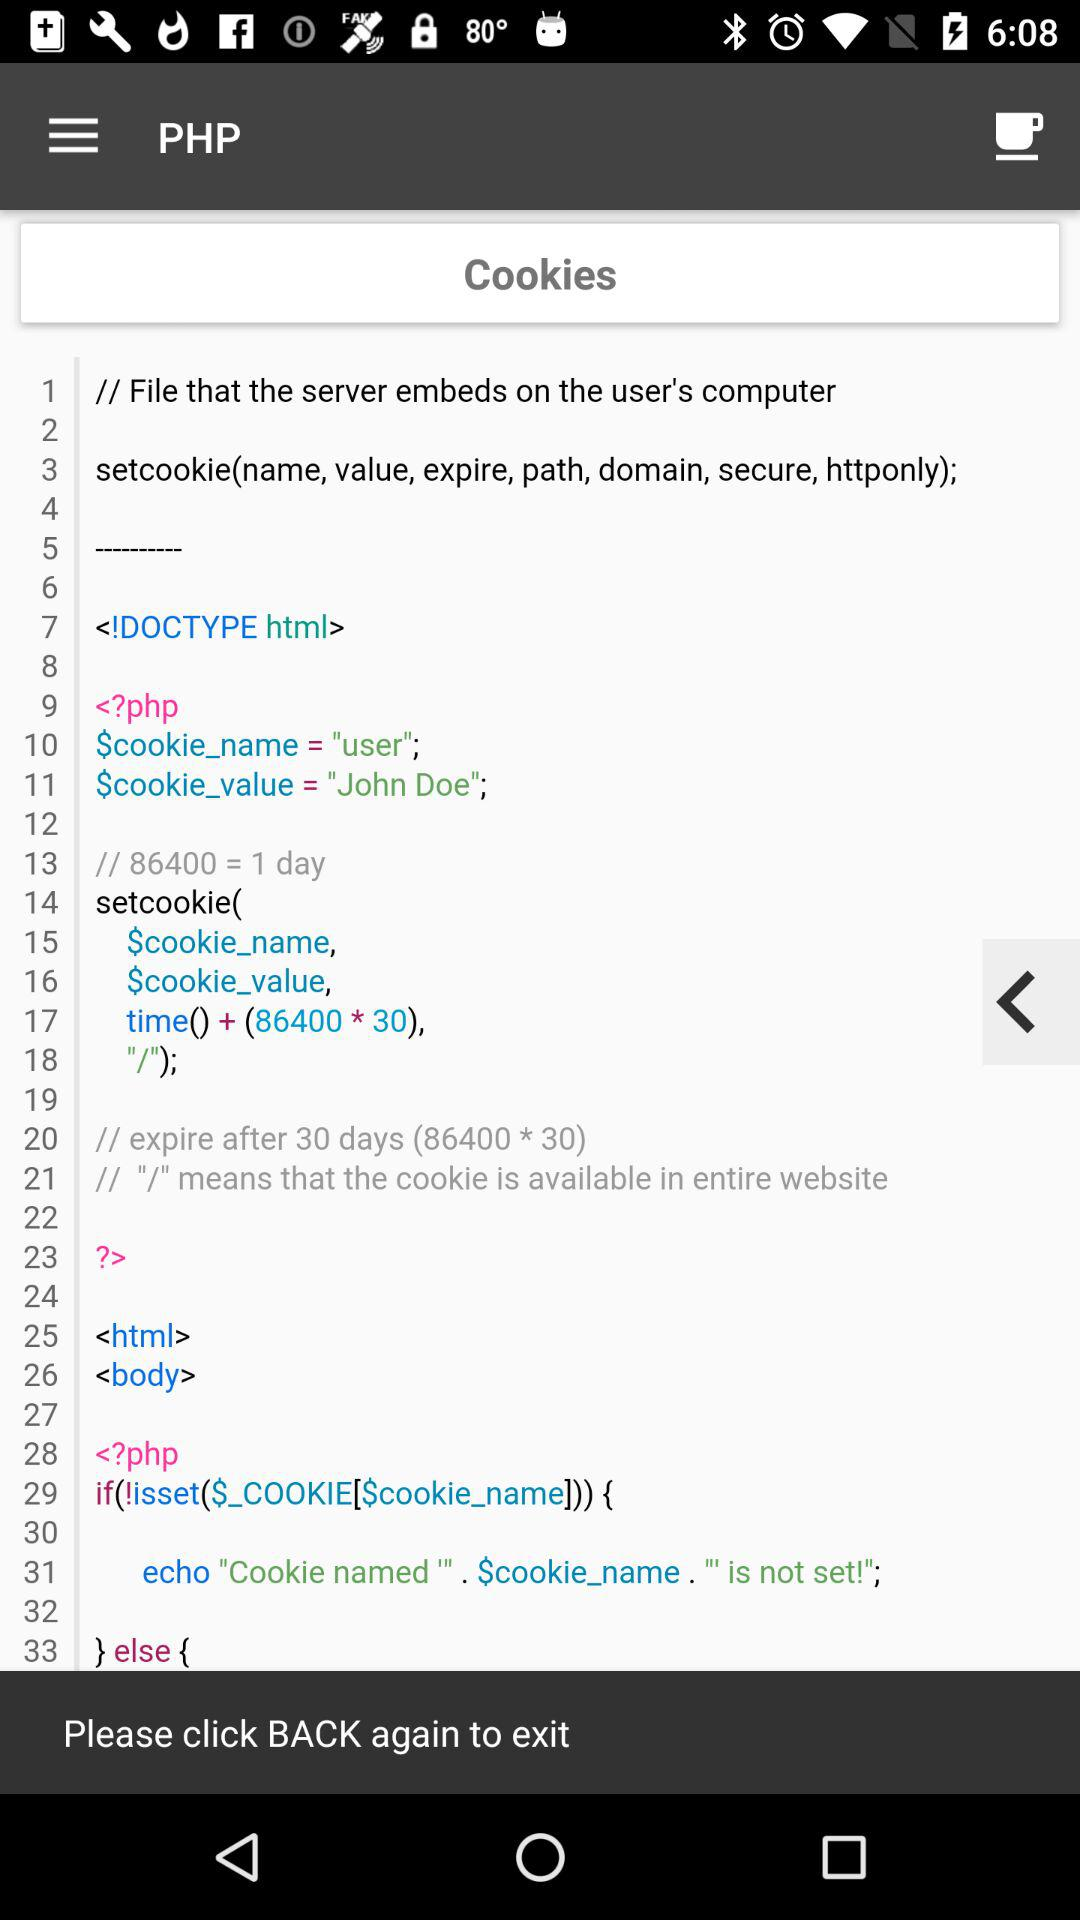What is the "$cookie_value"? The cookie value is "John Doe";. 